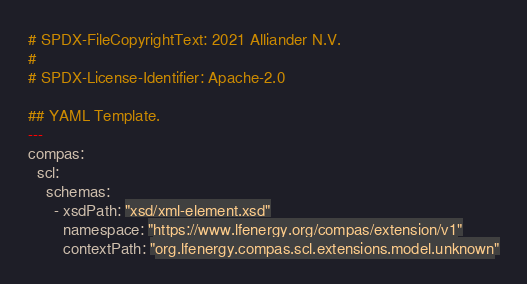<code> <loc_0><loc_0><loc_500><loc_500><_YAML_># SPDX-FileCopyrightText: 2021 Alliander N.V.
#
# SPDX-License-Identifier: Apache-2.0

## YAML Template.
---
compas:
  scl:
    schemas:
      - xsdPath: "xsd/xml-element.xsd"
        namespace: "https://www.lfenergy.org/compas/extension/v1"
        contextPath: "org.lfenergy.compas.scl.extensions.model.unknown"
</code> 